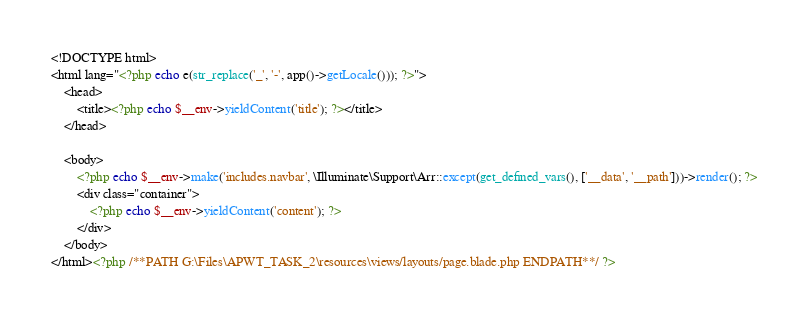<code> <loc_0><loc_0><loc_500><loc_500><_PHP_><!DOCTYPE html>
<html lang="<?php echo e(str_replace('_', '-', app()->getLocale())); ?>">
    <head>
        <title><?php echo $__env->yieldContent('title'); ?></title>
    </head>
    
    <body>
        <?php echo $__env->make('includes.navbar', \Illuminate\Support\Arr::except(get_defined_vars(), ['__data', '__path']))->render(); ?>
        <div class="container">
            <?php echo $__env->yieldContent('content'); ?>
        </div>
    </body>
</html><?php /**PATH G:\Files\APWT_TASK_2\resources\views/layouts/page.blade.php ENDPATH**/ ?></code> 